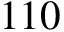Convert formula to latex. <formula><loc_0><loc_0><loc_500><loc_500>1 1 0</formula> 